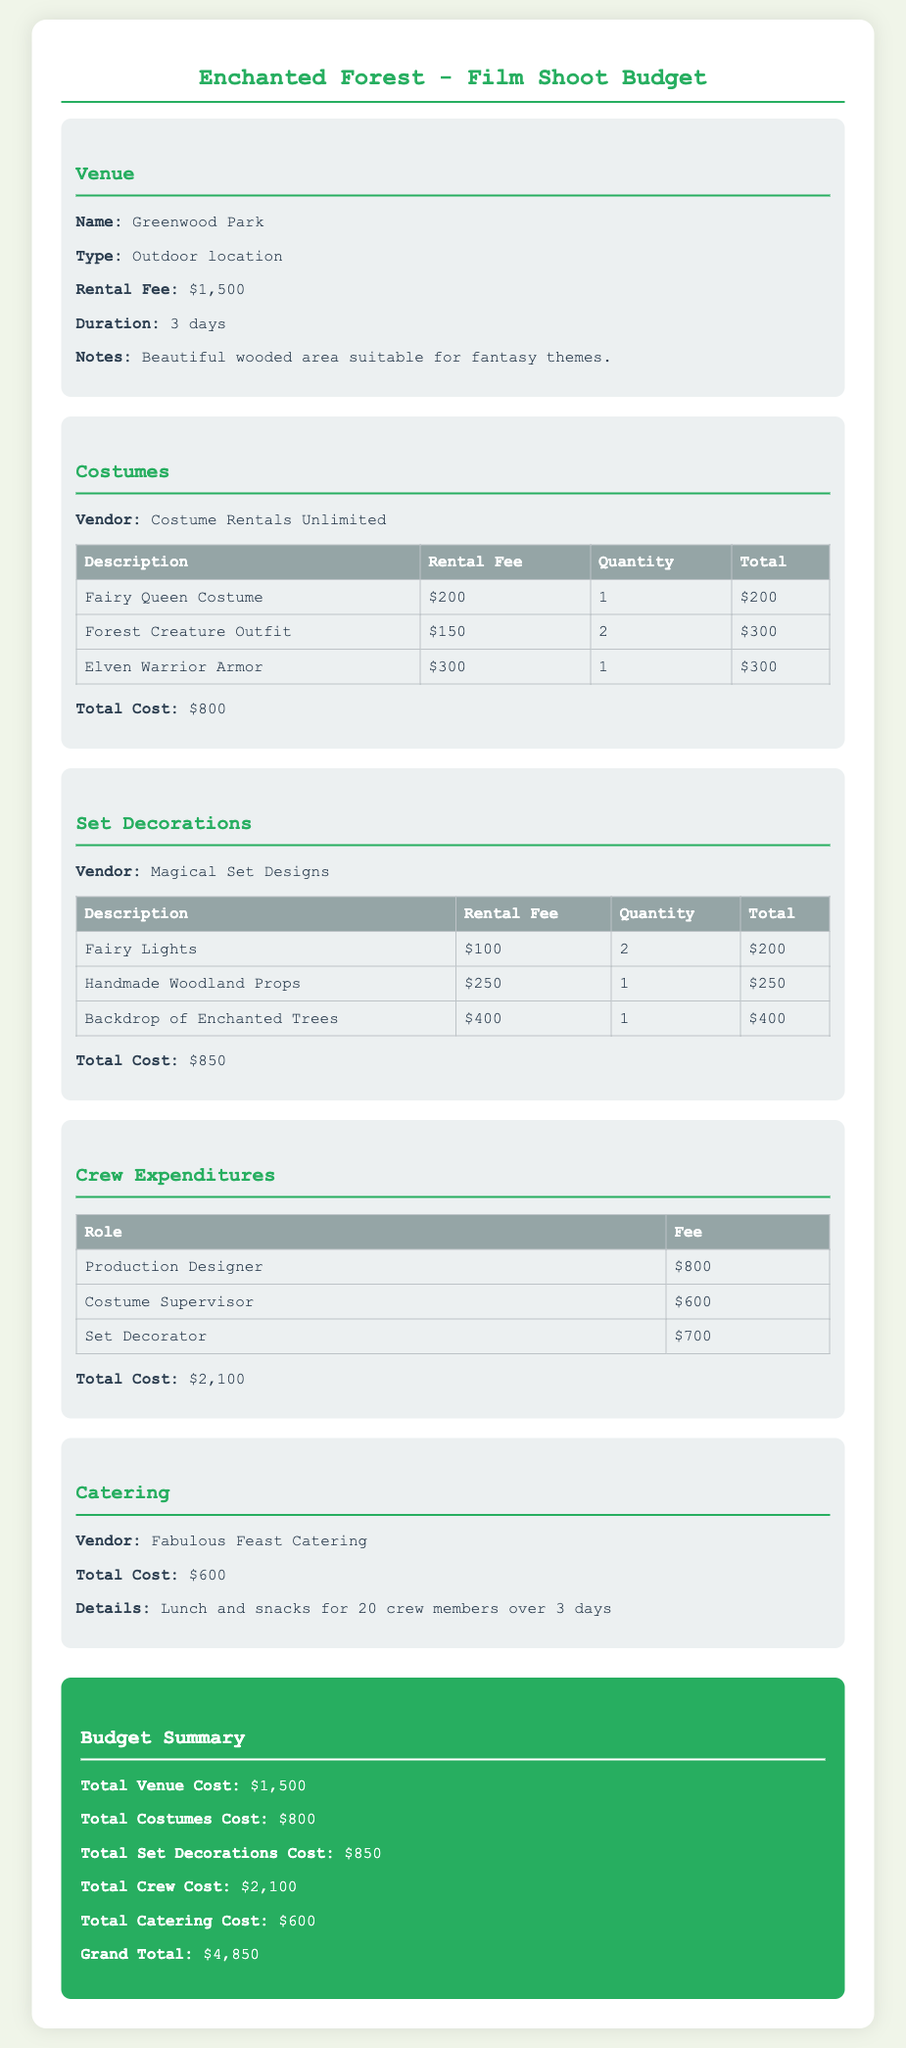What is the total venue cost? The total venue cost is listed in the budget section under Venue.
Answer: $1,500 How many days is the venue rented for? The duration for venue rental is mentioned in the Venue section.
Answer: 3 days What is the total cost for costumes? The document specifies the total cost of costumes in the Costumes section.
Answer: $800 What are the names of the two costume types rented? The document lists the costumes in the table under Costumes section.
Answer: Fairy Queen Costume, Forest Creature Outfit What is the rental fee for the Backdrop of Enchanted Trees? The rental fee for the backdrop is found in the Set Decorations table.
Answer: $400 What is the total cost for set decorations? The total cost of set decorations is summarized in the Set Decorations section.
Answer: $850 Who is the Production Designer? The role of Production Designer is mentioned in the Crew Expenditures section.
Answer: Not specified What is the total catering cost? The total catering cost is detailed in the Catering section of the budget document.
Answer: $600 What is the grand total of the budget? The grand total is presented in the Budget Summary at the end of the document.
Answer: $4,850 